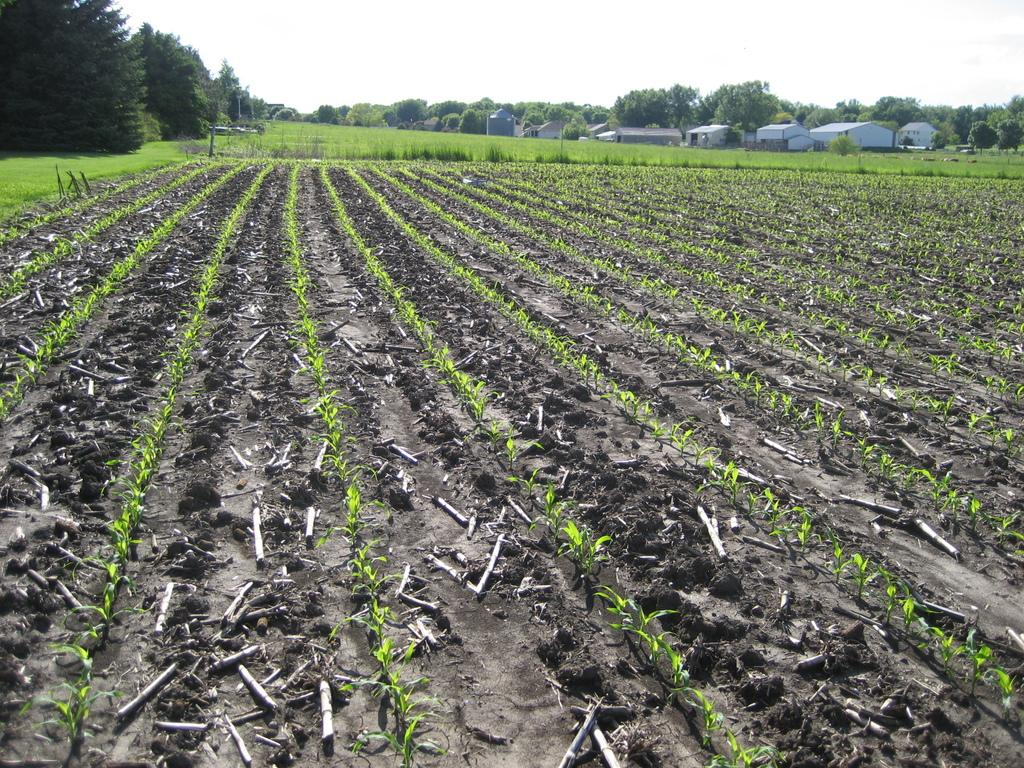What can be seen in the sky in the image? The sky is visible in the image. What type of vegetation is present in the image? There are trees in the image. What type of structures can be seen in the image? There are houses in the image. What type of ground cover is present in the image? There is grass in the image. What type of plants are planted in the soil in the image? There are plants planted in the soil in the image. Can you see the ocean in the image? No, the ocean is not present in the image. Is there a squirrel eating a meal in the image? No, there is no squirrel or meal present in the image. 